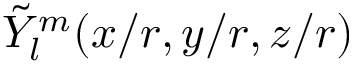Convert formula to latex. <formula><loc_0><loc_0><loc_500><loc_500>\tilde { Y } _ { l } ^ { m } ( x / r , y / r , z / r )</formula> 